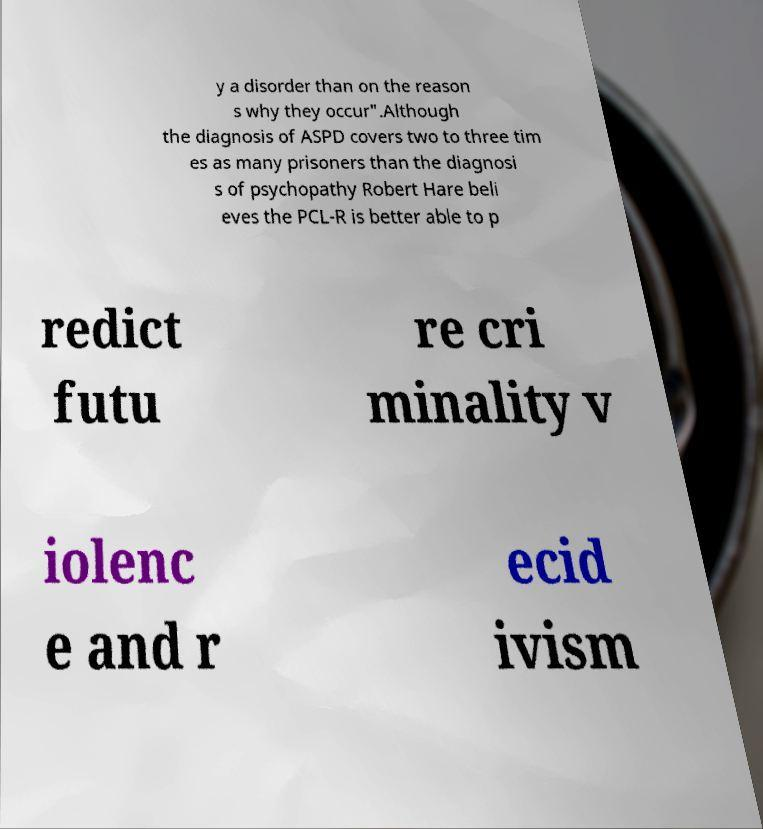Please identify and transcribe the text found in this image. y a disorder than on the reason s why they occur".Although the diagnosis of ASPD covers two to three tim es as many prisoners than the diagnosi s of psychopathy Robert Hare beli eves the PCL-R is better able to p redict futu re cri minality v iolenc e and r ecid ivism 